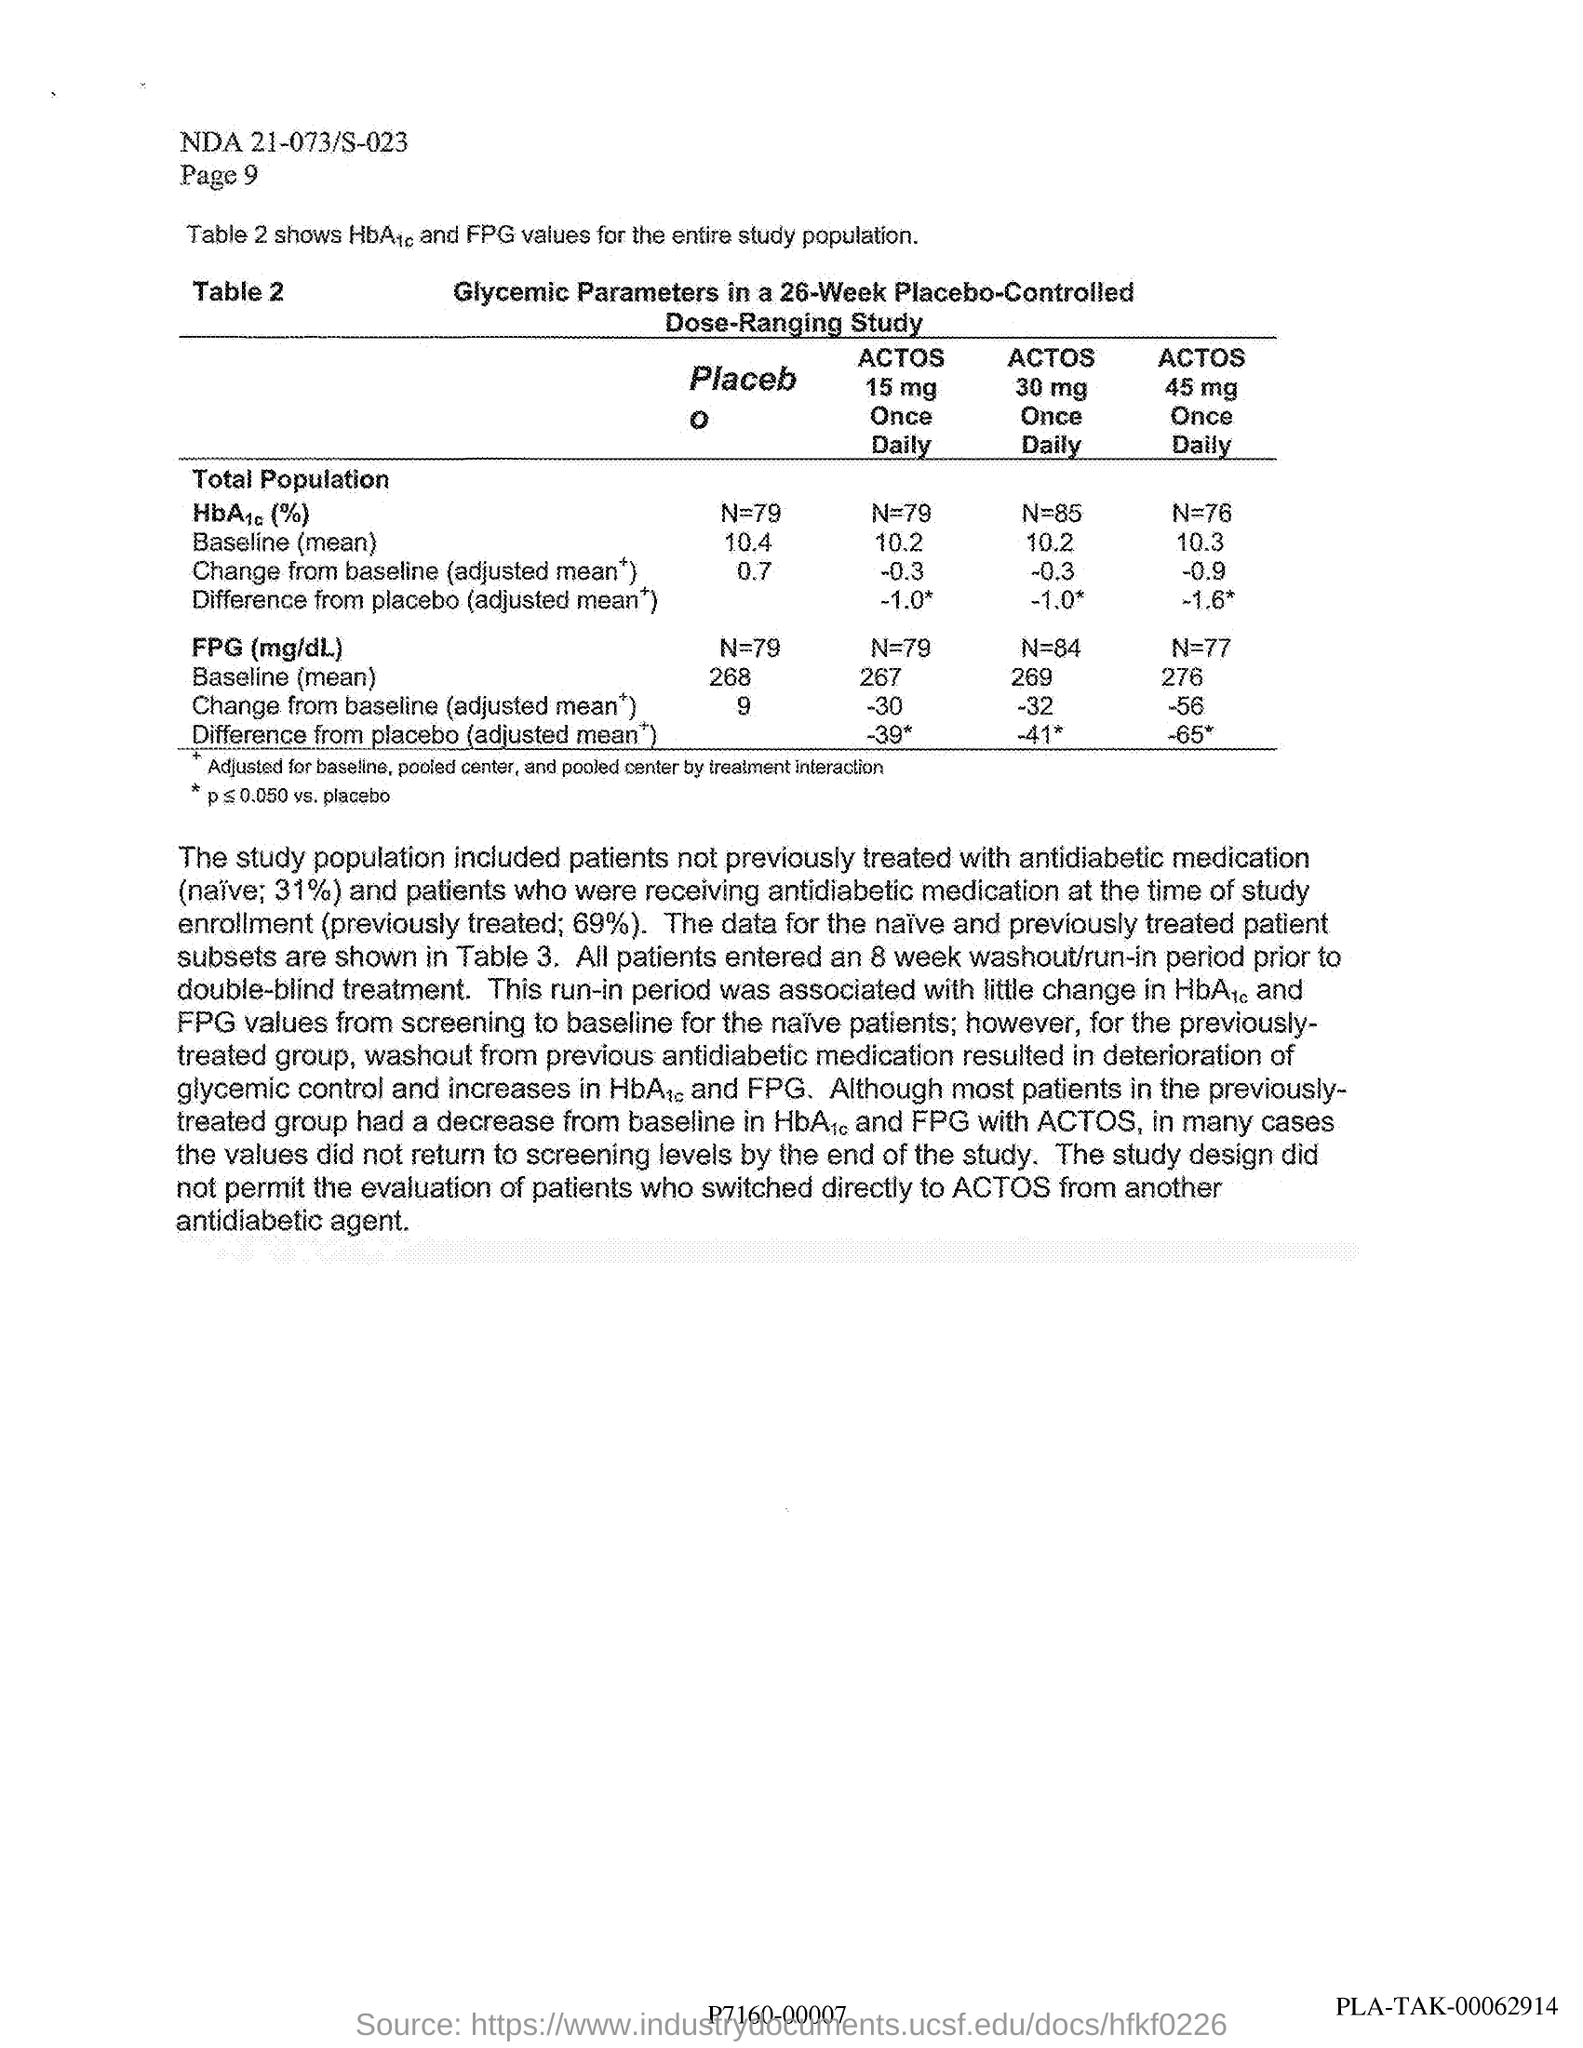Specify some key components in this picture. During the 8-week washout/run-in period preceding the double-blind treatment, the patients entered the study. The parameters considered in the study are specified in the heading of Table 2, which includes glycemic response. The study described in the table is a glycemic parameters in a 26-week placebo-controlled dose-ranging study. 